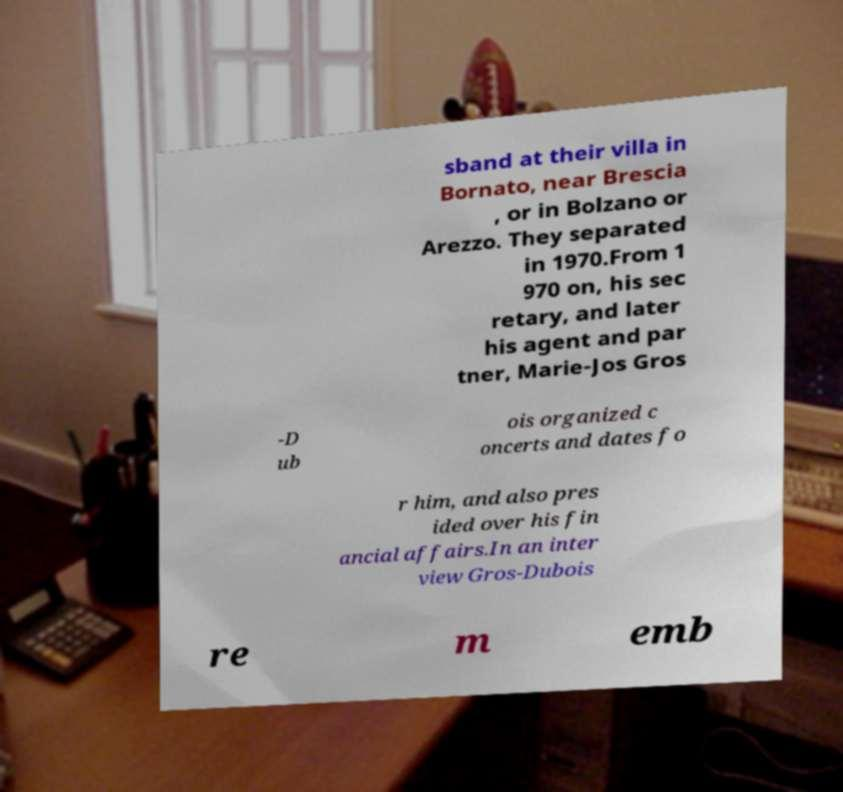Can you accurately transcribe the text from the provided image for me? sband at their villa in Bornato, near Brescia , or in Bolzano or Arezzo. They separated in 1970.From 1 970 on, his sec retary, and later his agent and par tner, Marie-Jos Gros -D ub ois organized c oncerts and dates fo r him, and also pres ided over his fin ancial affairs.In an inter view Gros-Dubois re m emb 